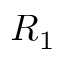<formula> <loc_0><loc_0><loc_500><loc_500>R _ { 1 }</formula> 